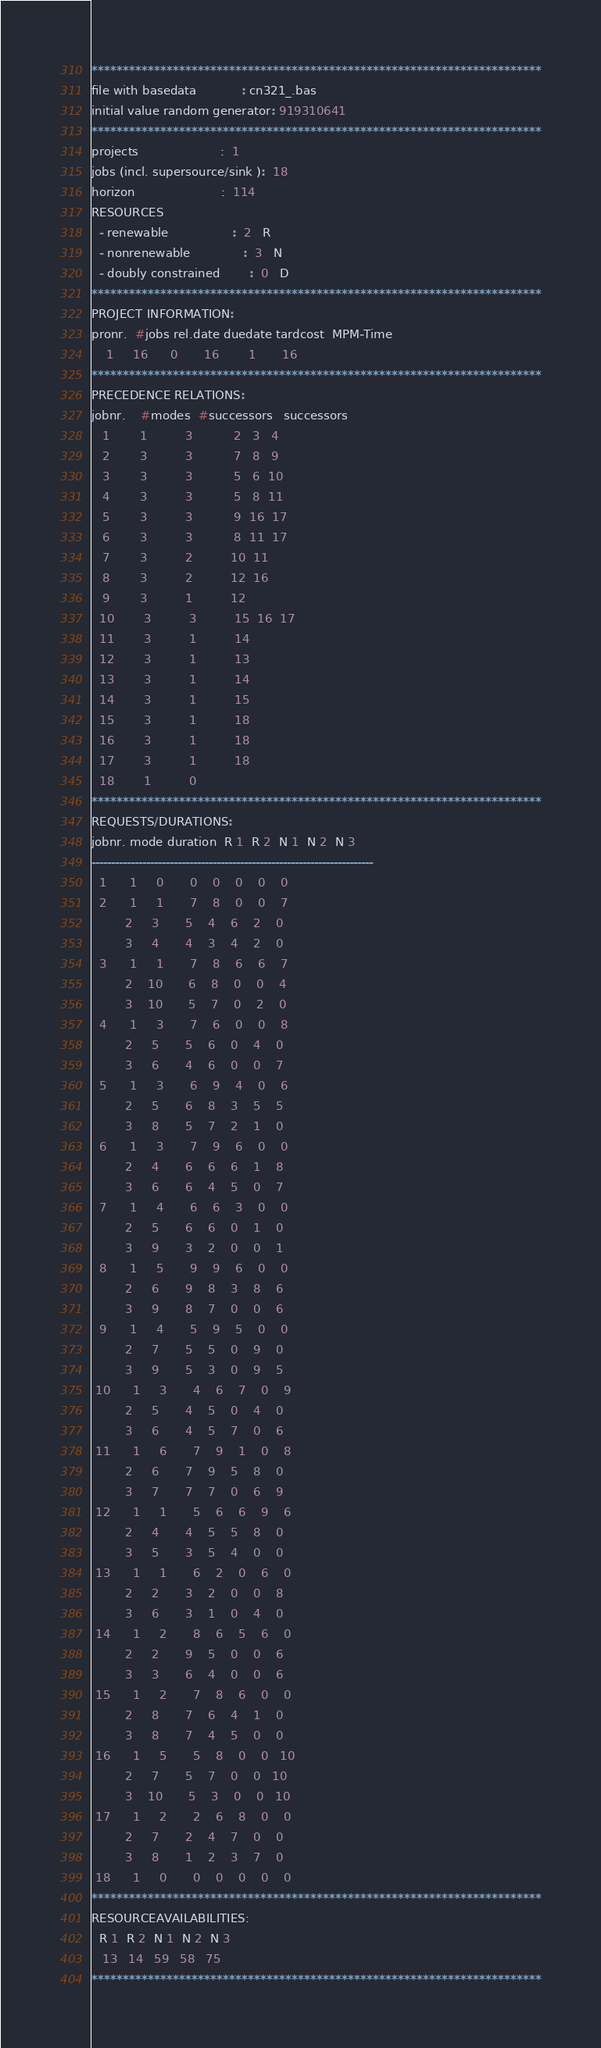Convert code to text. <code><loc_0><loc_0><loc_500><loc_500><_ObjectiveC_>************************************************************************
file with basedata            : cn321_.bas
initial value random generator: 919310641
************************************************************************
projects                      :  1
jobs (incl. supersource/sink ):  18
horizon                       :  114
RESOURCES
  - renewable                 :  2   R
  - nonrenewable              :  3   N
  - doubly constrained        :  0   D
************************************************************************
PROJECT INFORMATION:
pronr.  #jobs rel.date duedate tardcost  MPM-Time
    1     16      0       16        1       16
************************************************************************
PRECEDENCE RELATIONS:
jobnr.    #modes  #successors   successors
   1        1          3           2   3   4
   2        3          3           7   8   9
   3        3          3           5   6  10
   4        3          3           5   8  11
   5        3          3           9  16  17
   6        3          3           8  11  17
   7        3          2          10  11
   8        3          2          12  16
   9        3          1          12
  10        3          3          15  16  17
  11        3          1          14
  12        3          1          13
  13        3          1          14
  14        3          1          15
  15        3          1          18
  16        3          1          18
  17        3          1          18
  18        1          0        
************************************************************************
REQUESTS/DURATIONS:
jobnr. mode duration  R 1  R 2  N 1  N 2  N 3
------------------------------------------------------------------------
  1      1     0       0    0    0    0    0
  2      1     1       7    8    0    0    7
         2     3       5    4    6    2    0
         3     4       4    3    4    2    0
  3      1     1       7    8    6    6    7
         2    10       6    8    0    0    4
         3    10       5    7    0    2    0
  4      1     3       7    6    0    0    8
         2     5       5    6    0    4    0
         3     6       4    6    0    0    7
  5      1     3       6    9    4    0    6
         2     5       6    8    3    5    5
         3     8       5    7    2    1    0
  6      1     3       7    9    6    0    0
         2     4       6    6    6    1    8
         3     6       6    4    5    0    7
  7      1     4       6    6    3    0    0
         2     5       6    6    0    1    0
         3     9       3    2    0    0    1
  8      1     5       9    9    6    0    0
         2     6       9    8    3    8    6
         3     9       8    7    0    0    6
  9      1     4       5    9    5    0    0
         2     7       5    5    0    9    0
         3     9       5    3    0    9    5
 10      1     3       4    6    7    0    9
         2     5       4    5    0    4    0
         3     6       4    5    7    0    6
 11      1     6       7    9    1    0    8
         2     6       7    9    5    8    0
         3     7       7    7    0    6    9
 12      1     1       5    6    6    9    6
         2     4       4    5    5    8    0
         3     5       3    5    4    0    0
 13      1     1       6    2    0    6    0
         2     2       3    2    0    0    8
         3     6       3    1    0    4    0
 14      1     2       8    6    5    6    0
         2     2       9    5    0    0    6
         3     3       6    4    0    0    6
 15      1     2       7    8    6    0    0
         2     8       7    6    4    1    0
         3     8       7    4    5    0    0
 16      1     5       5    8    0    0   10
         2     7       5    7    0    0   10
         3    10       5    3    0    0   10
 17      1     2       2    6    8    0    0
         2     7       2    4    7    0    0
         3     8       1    2    3    7    0
 18      1     0       0    0    0    0    0
************************************************************************
RESOURCEAVAILABILITIES:
  R 1  R 2  N 1  N 2  N 3
   13   14   59   58   75
************************************************************************
</code> 